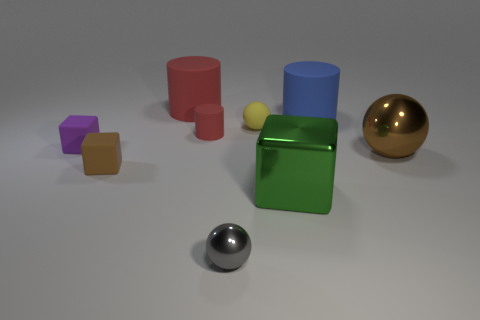What is the shape of the rubber thing that is the same color as the tiny cylinder?
Your answer should be compact. Cylinder. There is a matte thing that is right of the green object; is its color the same as the large metallic sphere?
Provide a succinct answer. No. There is a shiny thing that is right of the large cylinder that is right of the small metal object; what is its shape?
Your response must be concise. Sphere. How many things are matte things behind the blue rubber cylinder or spheres that are on the right side of the blue cylinder?
Provide a short and direct response. 2. There is a small red object that is made of the same material as the tiny brown object; what is its shape?
Your answer should be very brief. Cylinder. Is there any other thing that is the same color as the rubber sphere?
Make the answer very short. No. There is a tiny gray thing that is the same shape as the brown metallic object; what is it made of?
Give a very brief answer. Metal. How many other objects are there of the same size as the gray sphere?
Provide a short and direct response. 4. What is the tiny cylinder made of?
Your answer should be compact. Rubber. Are there more small red cylinders that are in front of the brown shiny thing than big gray matte cylinders?
Your response must be concise. No. 